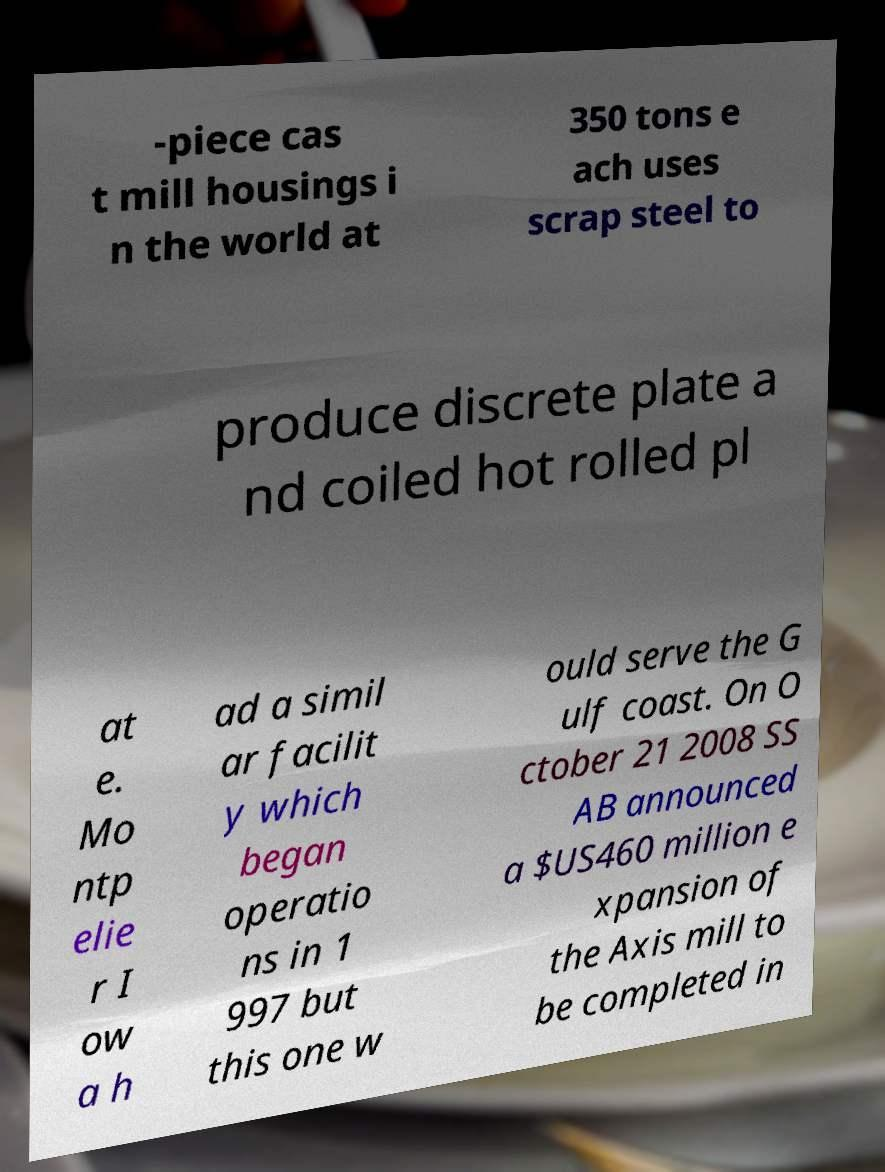For documentation purposes, I need the text within this image transcribed. Could you provide that? -piece cas t mill housings i n the world at 350 tons e ach uses scrap steel to produce discrete plate a nd coiled hot rolled pl at e. Mo ntp elie r I ow a h ad a simil ar facilit y which began operatio ns in 1 997 but this one w ould serve the G ulf coast. On O ctober 21 2008 SS AB announced a $US460 million e xpansion of the Axis mill to be completed in 